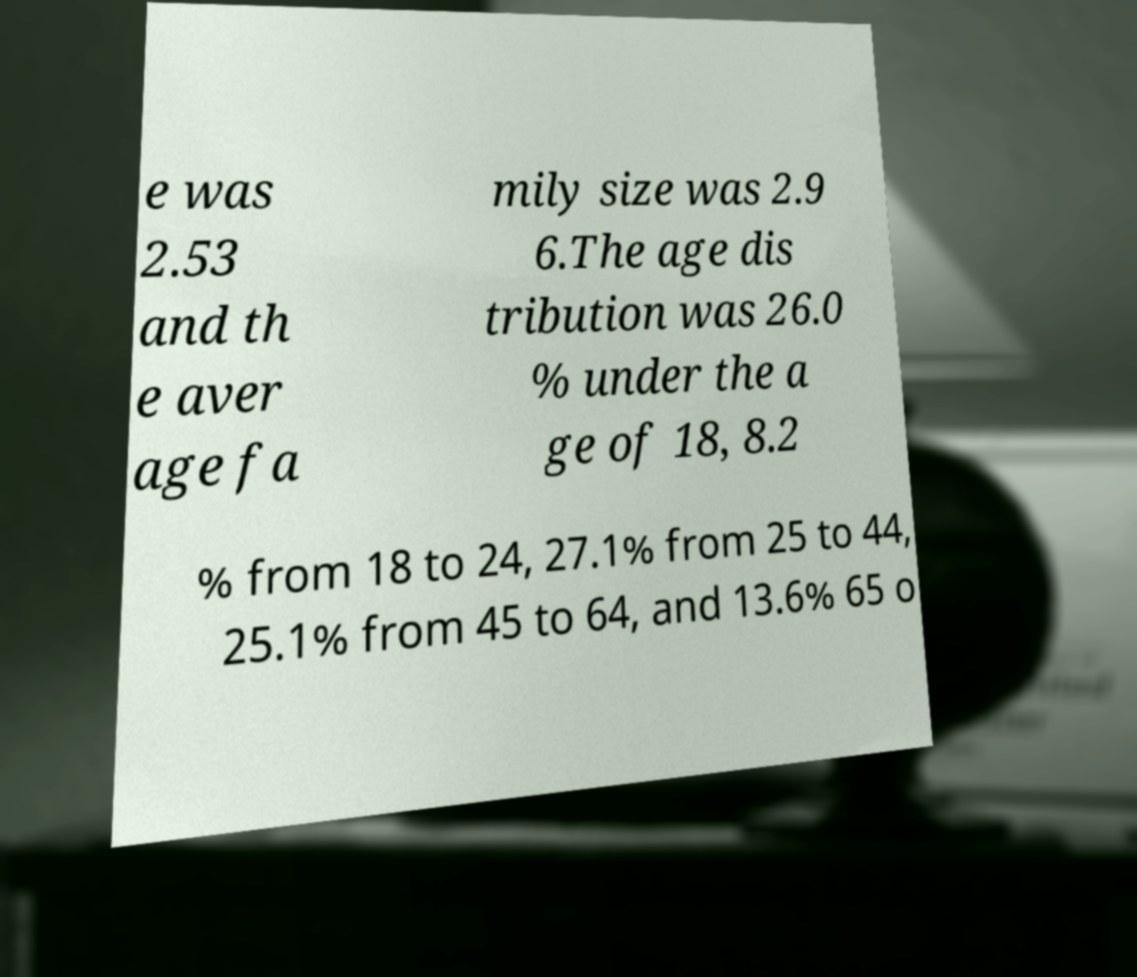Can you read and provide the text displayed in the image?This photo seems to have some interesting text. Can you extract and type it out for me? e was 2.53 and th e aver age fa mily size was 2.9 6.The age dis tribution was 26.0 % under the a ge of 18, 8.2 % from 18 to 24, 27.1% from 25 to 44, 25.1% from 45 to 64, and 13.6% 65 o 